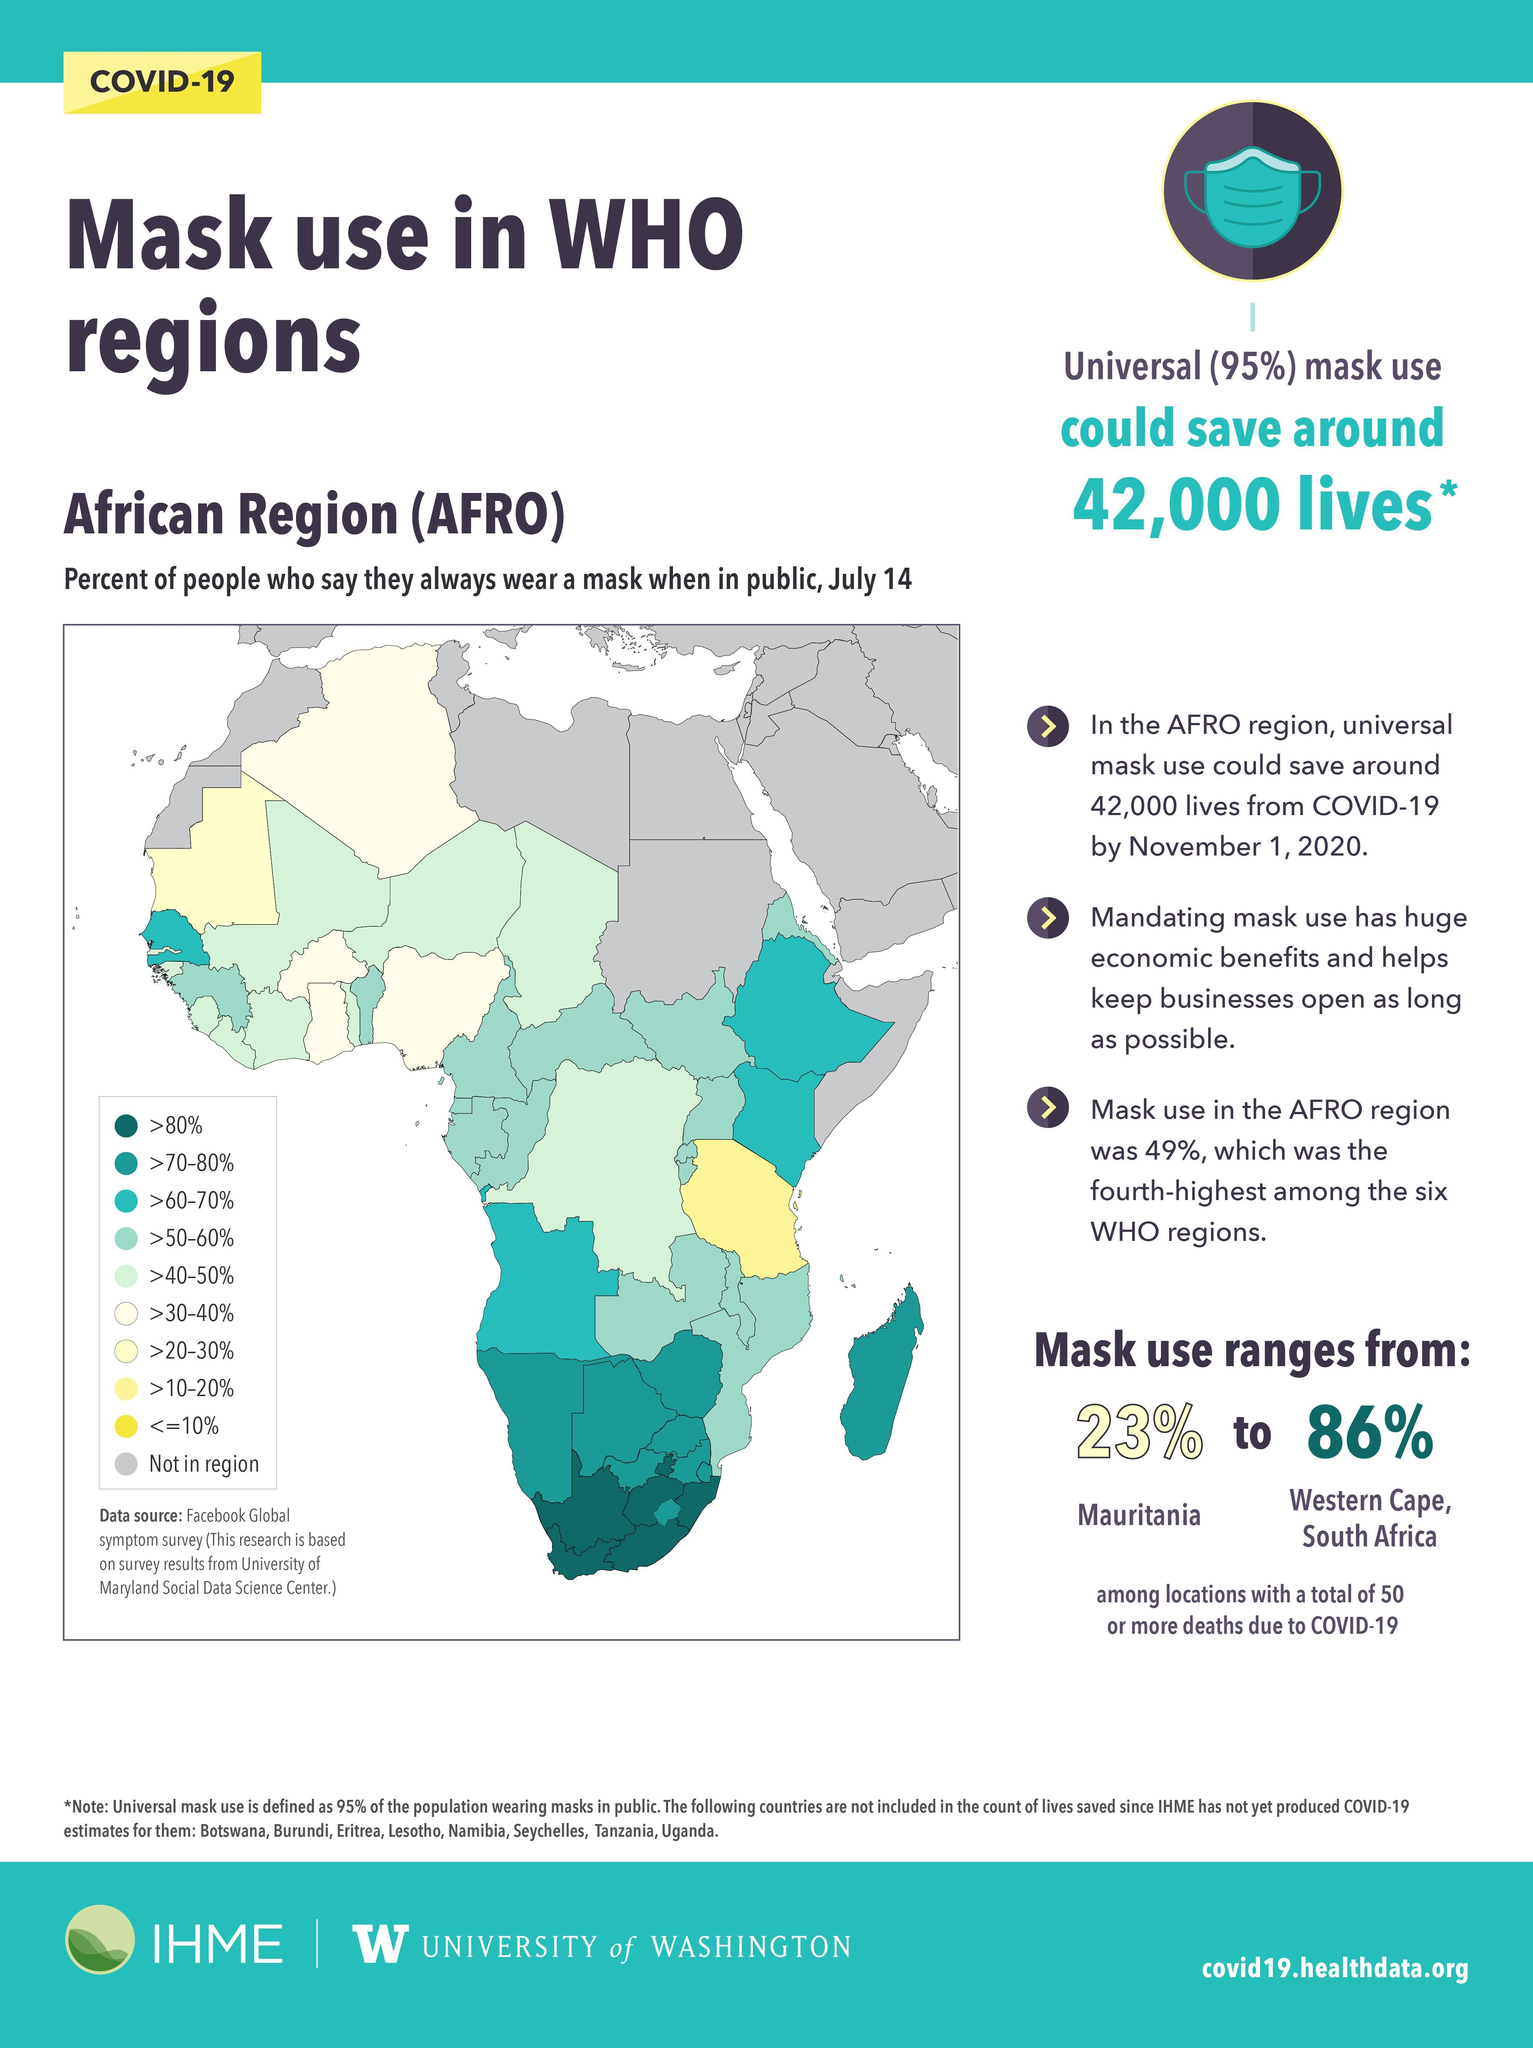In how many regions will >60-70% of people will always wear a mask in public?
Answer the question with a short phrase. 4 Which region has maximum mask use in AFRO areas? Western Cape, South Africa 